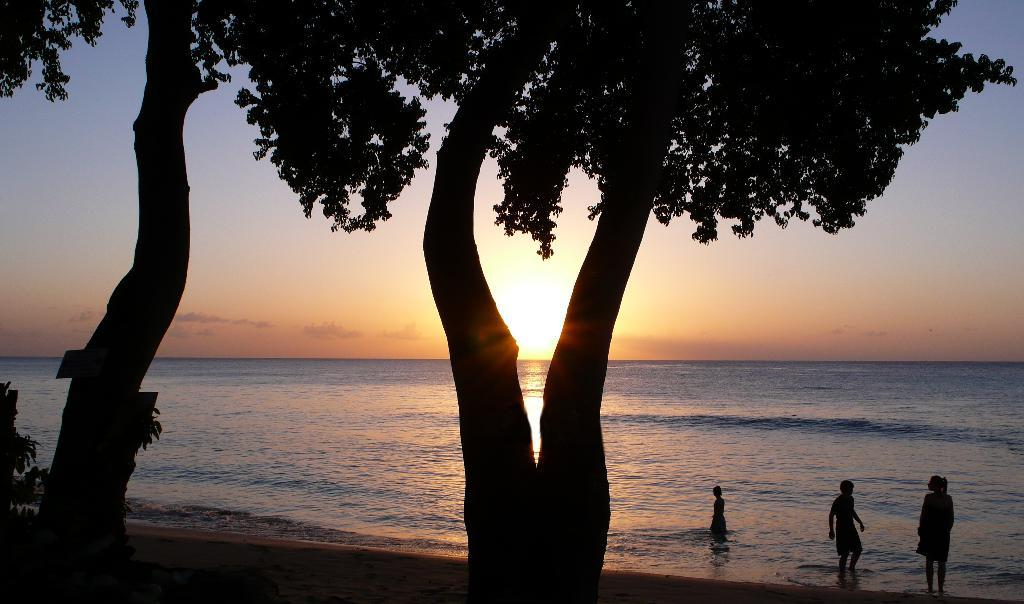How many people are in the water in the image? There are three persons in the water on the right side of the image. What else can be seen in the image besides the people in the water? Trees are visible in the image. What time of day does the image appear to depict? The sunset is observable in the image, suggesting that it is late afternoon or early evening. What type of bait is being used by the people in the water? There is no mention of bait or fishing in the image, so it cannot be determined what type of bait might be used. 